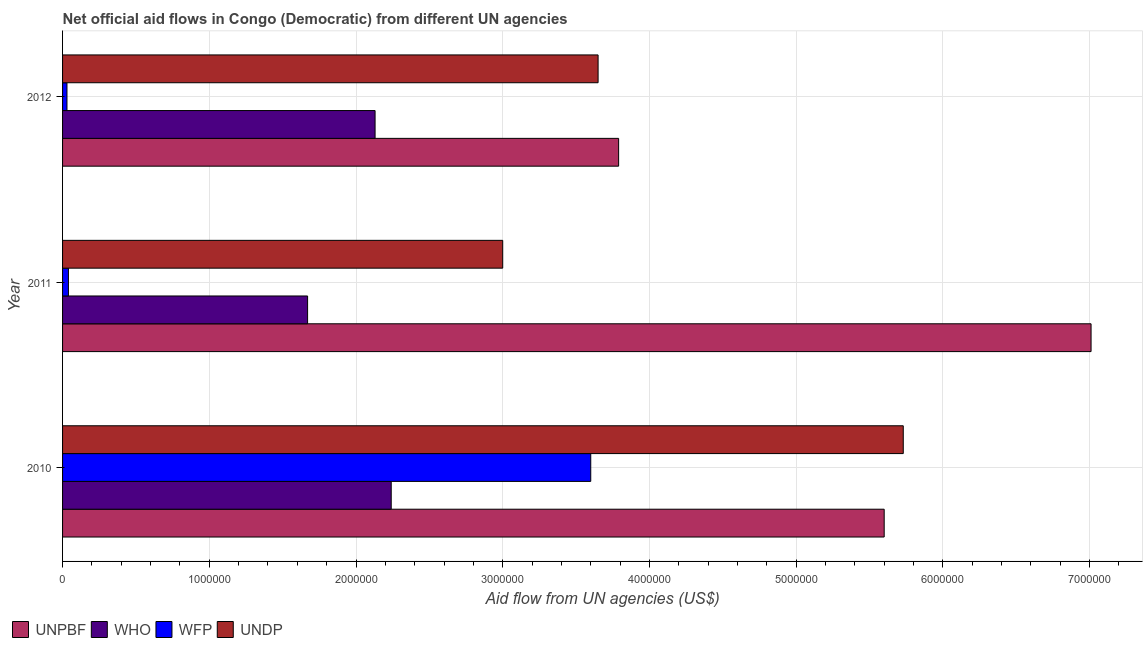How many groups of bars are there?
Provide a short and direct response. 3. Are the number of bars per tick equal to the number of legend labels?
Your answer should be very brief. Yes. Are the number of bars on each tick of the Y-axis equal?
Keep it short and to the point. Yes. What is the label of the 1st group of bars from the top?
Ensure brevity in your answer.  2012. What is the amount of aid given by unpbf in 2010?
Offer a terse response. 5.60e+06. Across all years, what is the maximum amount of aid given by unpbf?
Offer a very short reply. 7.01e+06. Across all years, what is the minimum amount of aid given by who?
Offer a terse response. 1.67e+06. In which year was the amount of aid given by unpbf maximum?
Your response must be concise. 2011. In which year was the amount of aid given by unpbf minimum?
Offer a very short reply. 2012. What is the total amount of aid given by wfp in the graph?
Make the answer very short. 3.67e+06. What is the difference between the amount of aid given by who in 2010 and that in 2011?
Keep it short and to the point. 5.70e+05. What is the difference between the amount of aid given by who in 2010 and the amount of aid given by wfp in 2011?
Keep it short and to the point. 2.20e+06. What is the average amount of aid given by wfp per year?
Make the answer very short. 1.22e+06. In the year 2011, what is the difference between the amount of aid given by who and amount of aid given by undp?
Keep it short and to the point. -1.33e+06. In how many years, is the amount of aid given by who greater than 4600000 US$?
Offer a terse response. 0. What is the ratio of the amount of aid given by who in 2011 to that in 2012?
Your answer should be compact. 0.78. Is the amount of aid given by undp in 2010 less than that in 2011?
Offer a very short reply. No. Is the difference between the amount of aid given by who in 2010 and 2011 greater than the difference between the amount of aid given by unpbf in 2010 and 2011?
Make the answer very short. Yes. What is the difference between the highest and the second highest amount of aid given by undp?
Provide a succinct answer. 2.08e+06. What is the difference between the highest and the lowest amount of aid given by wfp?
Offer a very short reply. 3.57e+06. In how many years, is the amount of aid given by who greater than the average amount of aid given by who taken over all years?
Your answer should be compact. 2. Is the sum of the amount of aid given by unpbf in 2010 and 2011 greater than the maximum amount of aid given by wfp across all years?
Ensure brevity in your answer.  Yes. What does the 3rd bar from the top in 2010 represents?
Ensure brevity in your answer.  WHO. What does the 3rd bar from the bottom in 2010 represents?
Give a very brief answer. WFP. How many years are there in the graph?
Keep it short and to the point. 3. What is the difference between two consecutive major ticks on the X-axis?
Offer a terse response. 1.00e+06. Does the graph contain grids?
Your answer should be compact. Yes. What is the title of the graph?
Make the answer very short. Net official aid flows in Congo (Democratic) from different UN agencies. What is the label or title of the X-axis?
Ensure brevity in your answer.  Aid flow from UN agencies (US$). What is the Aid flow from UN agencies (US$) in UNPBF in 2010?
Your answer should be compact. 5.60e+06. What is the Aid flow from UN agencies (US$) in WHO in 2010?
Your answer should be very brief. 2.24e+06. What is the Aid flow from UN agencies (US$) of WFP in 2010?
Give a very brief answer. 3.60e+06. What is the Aid flow from UN agencies (US$) in UNDP in 2010?
Your response must be concise. 5.73e+06. What is the Aid flow from UN agencies (US$) in UNPBF in 2011?
Provide a short and direct response. 7.01e+06. What is the Aid flow from UN agencies (US$) in WHO in 2011?
Ensure brevity in your answer.  1.67e+06. What is the Aid flow from UN agencies (US$) of WFP in 2011?
Make the answer very short. 4.00e+04. What is the Aid flow from UN agencies (US$) in UNPBF in 2012?
Provide a succinct answer. 3.79e+06. What is the Aid flow from UN agencies (US$) in WHO in 2012?
Offer a terse response. 2.13e+06. What is the Aid flow from UN agencies (US$) of UNDP in 2012?
Make the answer very short. 3.65e+06. Across all years, what is the maximum Aid flow from UN agencies (US$) of UNPBF?
Your answer should be very brief. 7.01e+06. Across all years, what is the maximum Aid flow from UN agencies (US$) of WHO?
Keep it short and to the point. 2.24e+06. Across all years, what is the maximum Aid flow from UN agencies (US$) in WFP?
Your answer should be compact. 3.60e+06. Across all years, what is the maximum Aid flow from UN agencies (US$) in UNDP?
Provide a succinct answer. 5.73e+06. Across all years, what is the minimum Aid flow from UN agencies (US$) in UNPBF?
Keep it short and to the point. 3.79e+06. Across all years, what is the minimum Aid flow from UN agencies (US$) of WHO?
Your response must be concise. 1.67e+06. Across all years, what is the minimum Aid flow from UN agencies (US$) in WFP?
Ensure brevity in your answer.  3.00e+04. What is the total Aid flow from UN agencies (US$) of UNPBF in the graph?
Ensure brevity in your answer.  1.64e+07. What is the total Aid flow from UN agencies (US$) of WHO in the graph?
Make the answer very short. 6.04e+06. What is the total Aid flow from UN agencies (US$) in WFP in the graph?
Your answer should be compact. 3.67e+06. What is the total Aid flow from UN agencies (US$) of UNDP in the graph?
Your answer should be compact. 1.24e+07. What is the difference between the Aid flow from UN agencies (US$) of UNPBF in 2010 and that in 2011?
Your response must be concise. -1.41e+06. What is the difference between the Aid flow from UN agencies (US$) of WHO in 2010 and that in 2011?
Ensure brevity in your answer.  5.70e+05. What is the difference between the Aid flow from UN agencies (US$) of WFP in 2010 and that in 2011?
Your answer should be compact. 3.56e+06. What is the difference between the Aid flow from UN agencies (US$) in UNDP in 2010 and that in 2011?
Give a very brief answer. 2.73e+06. What is the difference between the Aid flow from UN agencies (US$) of UNPBF in 2010 and that in 2012?
Provide a short and direct response. 1.81e+06. What is the difference between the Aid flow from UN agencies (US$) in WHO in 2010 and that in 2012?
Make the answer very short. 1.10e+05. What is the difference between the Aid flow from UN agencies (US$) in WFP in 2010 and that in 2012?
Keep it short and to the point. 3.57e+06. What is the difference between the Aid flow from UN agencies (US$) of UNDP in 2010 and that in 2012?
Make the answer very short. 2.08e+06. What is the difference between the Aid flow from UN agencies (US$) of UNPBF in 2011 and that in 2012?
Your answer should be very brief. 3.22e+06. What is the difference between the Aid flow from UN agencies (US$) in WHO in 2011 and that in 2012?
Your response must be concise. -4.60e+05. What is the difference between the Aid flow from UN agencies (US$) in UNDP in 2011 and that in 2012?
Make the answer very short. -6.50e+05. What is the difference between the Aid flow from UN agencies (US$) in UNPBF in 2010 and the Aid flow from UN agencies (US$) in WHO in 2011?
Your answer should be very brief. 3.93e+06. What is the difference between the Aid flow from UN agencies (US$) in UNPBF in 2010 and the Aid flow from UN agencies (US$) in WFP in 2011?
Offer a terse response. 5.56e+06. What is the difference between the Aid flow from UN agencies (US$) in UNPBF in 2010 and the Aid flow from UN agencies (US$) in UNDP in 2011?
Your answer should be compact. 2.60e+06. What is the difference between the Aid flow from UN agencies (US$) in WHO in 2010 and the Aid flow from UN agencies (US$) in WFP in 2011?
Ensure brevity in your answer.  2.20e+06. What is the difference between the Aid flow from UN agencies (US$) of WHO in 2010 and the Aid flow from UN agencies (US$) of UNDP in 2011?
Your answer should be very brief. -7.60e+05. What is the difference between the Aid flow from UN agencies (US$) in WFP in 2010 and the Aid flow from UN agencies (US$) in UNDP in 2011?
Give a very brief answer. 6.00e+05. What is the difference between the Aid flow from UN agencies (US$) in UNPBF in 2010 and the Aid flow from UN agencies (US$) in WHO in 2012?
Your answer should be very brief. 3.47e+06. What is the difference between the Aid flow from UN agencies (US$) in UNPBF in 2010 and the Aid flow from UN agencies (US$) in WFP in 2012?
Keep it short and to the point. 5.57e+06. What is the difference between the Aid flow from UN agencies (US$) in UNPBF in 2010 and the Aid flow from UN agencies (US$) in UNDP in 2012?
Keep it short and to the point. 1.95e+06. What is the difference between the Aid flow from UN agencies (US$) in WHO in 2010 and the Aid flow from UN agencies (US$) in WFP in 2012?
Your answer should be very brief. 2.21e+06. What is the difference between the Aid flow from UN agencies (US$) in WHO in 2010 and the Aid flow from UN agencies (US$) in UNDP in 2012?
Give a very brief answer. -1.41e+06. What is the difference between the Aid flow from UN agencies (US$) in WFP in 2010 and the Aid flow from UN agencies (US$) in UNDP in 2012?
Offer a terse response. -5.00e+04. What is the difference between the Aid flow from UN agencies (US$) in UNPBF in 2011 and the Aid flow from UN agencies (US$) in WHO in 2012?
Your answer should be compact. 4.88e+06. What is the difference between the Aid flow from UN agencies (US$) of UNPBF in 2011 and the Aid flow from UN agencies (US$) of WFP in 2012?
Ensure brevity in your answer.  6.98e+06. What is the difference between the Aid flow from UN agencies (US$) of UNPBF in 2011 and the Aid flow from UN agencies (US$) of UNDP in 2012?
Give a very brief answer. 3.36e+06. What is the difference between the Aid flow from UN agencies (US$) in WHO in 2011 and the Aid flow from UN agencies (US$) in WFP in 2012?
Offer a terse response. 1.64e+06. What is the difference between the Aid flow from UN agencies (US$) in WHO in 2011 and the Aid flow from UN agencies (US$) in UNDP in 2012?
Keep it short and to the point. -1.98e+06. What is the difference between the Aid flow from UN agencies (US$) of WFP in 2011 and the Aid flow from UN agencies (US$) of UNDP in 2012?
Your answer should be compact. -3.61e+06. What is the average Aid flow from UN agencies (US$) in UNPBF per year?
Offer a very short reply. 5.47e+06. What is the average Aid flow from UN agencies (US$) of WHO per year?
Your response must be concise. 2.01e+06. What is the average Aid flow from UN agencies (US$) of WFP per year?
Offer a terse response. 1.22e+06. What is the average Aid flow from UN agencies (US$) in UNDP per year?
Your response must be concise. 4.13e+06. In the year 2010, what is the difference between the Aid flow from UN agencies (US$) of UNPBF and Aid flow from UN agencies (US$) of WHO?
Provide a short and direct response. 3.36e+06. In the year 2010, what is the difference between the Aid flow from UN agencies (US$) of WHO and Aid flow from UN agencies (US$) of WFP?
Give a very brief answer. -1.36e+06. In the year 2010, what is the difference between the Aid flow from UN agencies (US$) of WHO and Aid flow from UN agencies (US$) of UNDP?
Make the answer very short. -3.49e+06. In the year 2010, what is the difference between the Aid flow from UN agencies (US$) in WFP and Aid flow from UN agencies (US$) in UNDP?
Ensure brevity in your answer.  -2.13e+06. In the year 2011, what is the difference between the Aid flow from UN agencies (US$) of UNPBF and Aid flow from UN agencies (US$) of WHO?
Ensure brevity in your answer.  5.34e+06. In the year 2011, what is the difference between the Aid flow from UN agencies (US$) of UNPBF and Aid flow from UN agencies (US$) of WFP?
Your answer should be compact. 6.97e+06. In the year 2011, what is the difference between the Aid flow from UN agencies (US$) in UNPBF and Aid flow from UN agencies (US$) in UNDP?
Provide a short and direct response. 4.01e+06. In the year 2011, what is the difference between the Aid flow from UN agencies (US$) of WHO and Aid flow from UN agencies (US$) of WFP?
Make the answer very short. 1.63e+06. In the year 2011, what is the difference between the Aid flow from UN agencies (US$) of WHO and Aid flow from UN agencies (US$) of UNDP?
Keep it short and to the point. -1.33e+06. In the year 2011, what is the difference between the Aid flow from UN agencies (US$) of WFP and Aid flow from UN agencies (US$) of UNDP?
Provide a short and direct response. -2.96e+06. In the year 2012, what is the difference between the Aid flow from UN agencies (US$) of UNPBF and Aid flow from UN agencies (US$) of WHO?
Your response must be concise. 1.66e+06. In the year 2012, what is the difference between the Aid flow from UN agencies (US$) of UNPBF and Aid flow from UN agencies (US$) of WFP?
Your answer should be very brief. 3.76e+06. In the year 2012, what is the difference between the Aid flow from UN agencies (US$) of WHO and Aid flow from UN agencies (US$) of WFP?
Provide a short and direct response. 2.10e+06. In the year 2012, what is the difference between the Aid flow from UN agencies (US$) of WHO and Aid flow from UN agencies (US$) of UNDP?
Ensure brevity in your answer.  -1.52e+06. In the year 2012, what is the difference between the Aid flow from UN agencies (US$) in WFP and Aid flow from UN agencies (US$) in UNDP?
Offer a terse response. -3.62e+06. What is the ratio of the Aid flow from UN agencies (US$) in UNPBF in 2010 to that in 2011?
Offer a terse response. 0.8. What is the ratio of the Aid flow from UN agencies (US$) in WHO in 2010 to that in 2011?
Your response must be concise. 1.34. What is the ratio of the Aid flow from UN agencies (US$) in WFP in 2010 to that in 2011?
Your response must be concise. 90. What is the ratio of the Aid flow from UN agencies (US$) in UNDP in 2010 to that in 2011?
Ensure brevity in your answer.  1.91. What is the ratio of the Aid flow from UN agencies (US$) in UNPBF in 2010 to that in 2012?
Offer a terse response. 1.48. What is the ratio of the Aid flow from UN agencies (US$) of WHO in 2010 to that in 2012?
Offer a very short reply. 1.05. What is the ratio of the Aid flow from UN agencies (US$) of WFP in 2010 to that in 2012?
Ensure brevity in your answer.  120. What is the ratio of the Aid flow from UN agencies (US$) in UNDP in 2010 to that in 2012?
Your answer should be compact. 1.57. What is the ratio of the Aid flow from UN agencies (US$) in UNPBF in 2011 to that in 2012?
Give a very brief answer. 1.85. What is the ratio of the Aid flow from UN agencies (US$) of WHO in 2011 to that in 2012?
Your answer should be compact. 0.78. What is the ratio of the Aid flow from UN agencies (US$) of UNDP in 2011 to that in 2012?
Offer a very short reply. 0.82. What is the difference between the highest and the second highest Aid flow from UN agencies (US$) of UNPBF?
Your answer should be compact. 1.41e+06. What is the difference between the highest and the second highest Aid flow from UN agencies (US$) of WFP?
Your answer should be compact. 3.56e+06. What is the difference between the highest and the second highest Aid flow from UN agencies (US$) of UNDP?
Offer a terse response. 2.08e+06. What is the difference between the highest and the lowest Aid flow from UN agencies (US$) in UNPBF?
Ensure brevity in your answer.  3.22e+06. What is the difference between the highest and the lowest Aid flow from UN agencies (US$) in WHO?
Give a very brief answer. 5.70e+05. What is the difference between the highest and the lowest Aid flow from UN agencies (US$) in WFP?
Keep it short and to the point. 3.57e+06. What is the difference between the highest and the lowest Aid flow from UN agencies (US$) of UNDP?
Offer a terse response. 2.73e+06. 